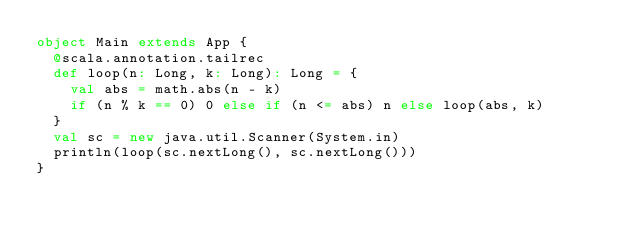<code> <loc_0><loc_0><loc_500><loc_500><_Scala_>object Main extends App {
  @scala.annotation.tailrec
  def loop(n: Long, k: Long): Long = {
    val abs = math.abs(n - k)
    if (n % k == 0) 0 else if (n <= abs) n else loop(abs, k)
  }
  val sc = new java.util.Scanner(System.in)
  println(loop(sc.nextLong(), sc.nextLong()))
}
</code> 